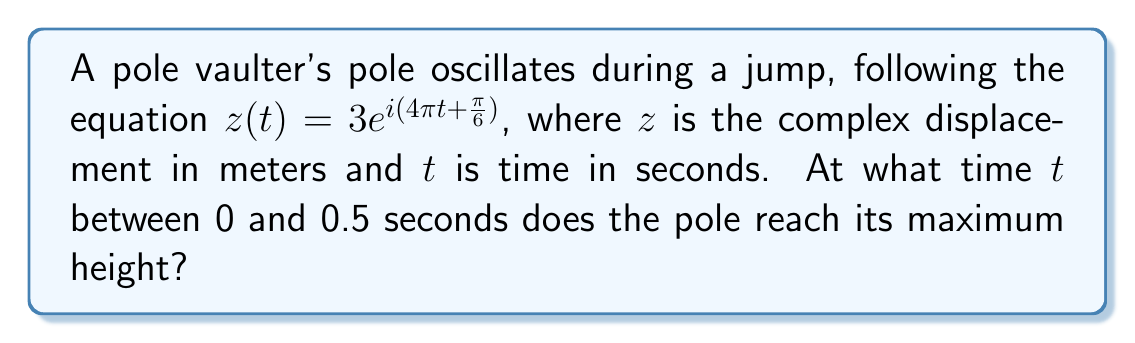Can you answer this question? Let's approach this step-by-step:

1) The given equation is in the form of Euler's formula: $z(t) = re^{i(\omega t + \phi)}$
   Where $r = 3$, $\omega = 4\pi$, and $\phi = \frac{\pi}{6}$

2) To find the height, we need the imaginary part of $z(t)$:
   $\text{Im}(z(t)) = 3\sin(4\pi t + \frac{\pi}{6})$

3) The maximum height occurs when the sine function reaches its peak, which happens when its argument is $\frac{\pi}{2}$ (or any odd multiple of $\frac{\pi}{2}$).

4) So, we need to solve:
   $4\pi t + \frac{\pi}{6} = \frac{\pi}{2}$

5) Solving for $t$:
   $4\pi t = \frac{\pi}{2} - \frac{\pi}{6} = \frac{\pi}{3}$
   $t = \frac{1}{12}$ seconds

6) We need to check if this time is within the given range of 0 to 0.5 seconds:
   $0 < \frac{1}{12} < 0.5$, so it is within the range.

Therefore, the pole reaches its maximum height at $t = \frac{1}{12}$ seconds.
Answer: $\frac{1}{12}$ seconds 